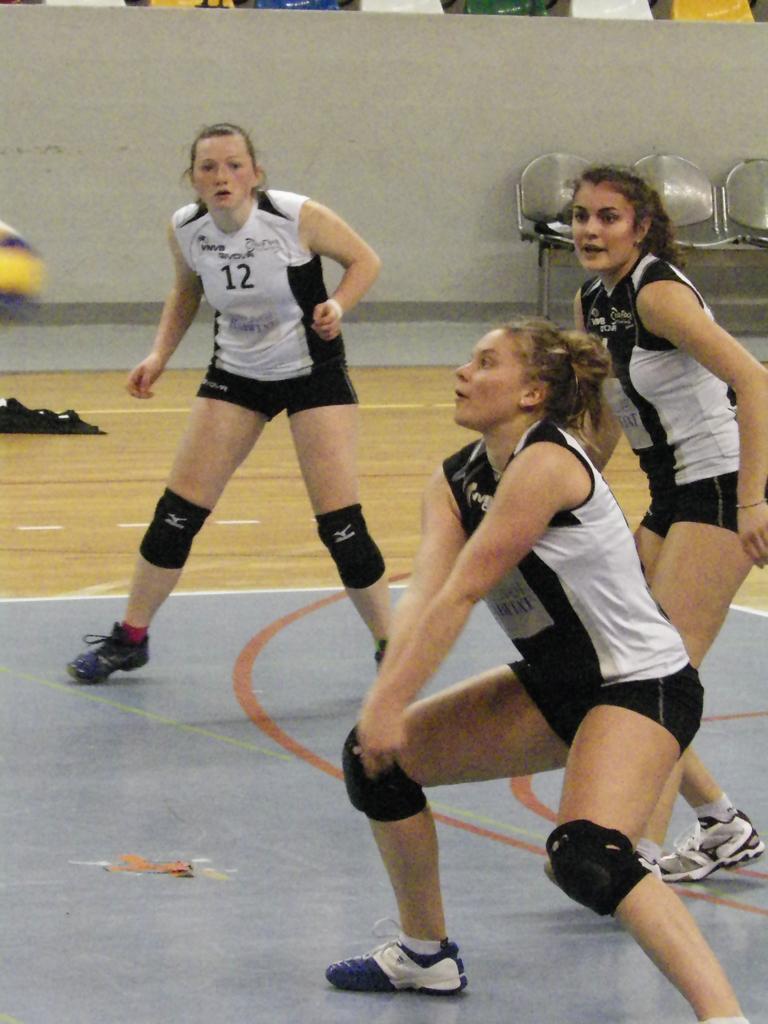Describe this image in one or two sentences. In this picture, we can see three persons standing on the floor and we can see some objects on the floor and in the background we can see a wall and some chairs. 